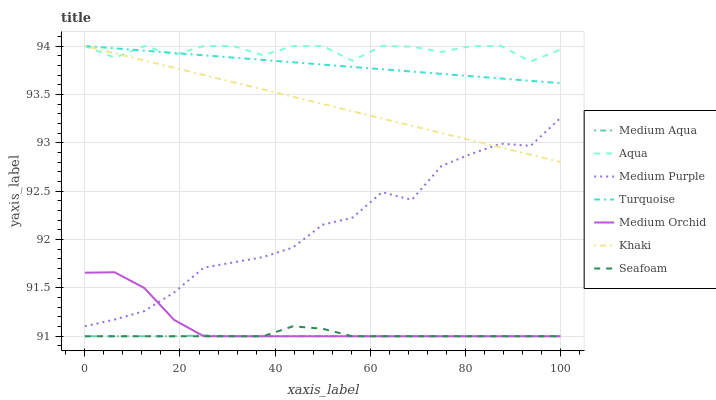Does Khaki have the minimum area under the curve?
Answer yes or no. No. Does Khaki have the maximum area under the curve?
Answer yes or no. No. Is Khaki the smoothest?
Answer yes or no. No. Is Khaki the roughest?
Answer yes or no. No. Does Khaki have the lowest value?
Answer yes or no. No. Does Medium Orchid have the highest value?
Answer yes or no. No. Is Medium Aqua less than Aqua?
Answer yes or no. Yes. Is Aqua greater than Medium Purple?
Answer yes or no. Yes. Does Medium Aqua intersect Aqua?
Answer yes or no. No. 